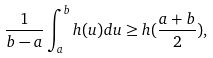<formula> <loc_0><loc_0><loc_500><loc_500>\frac { 1 } { b - a } \int ^ { b } _ { a } h ( u ) d u \geq h ( \frac { a + b } { 2 } ) ,</formula> 